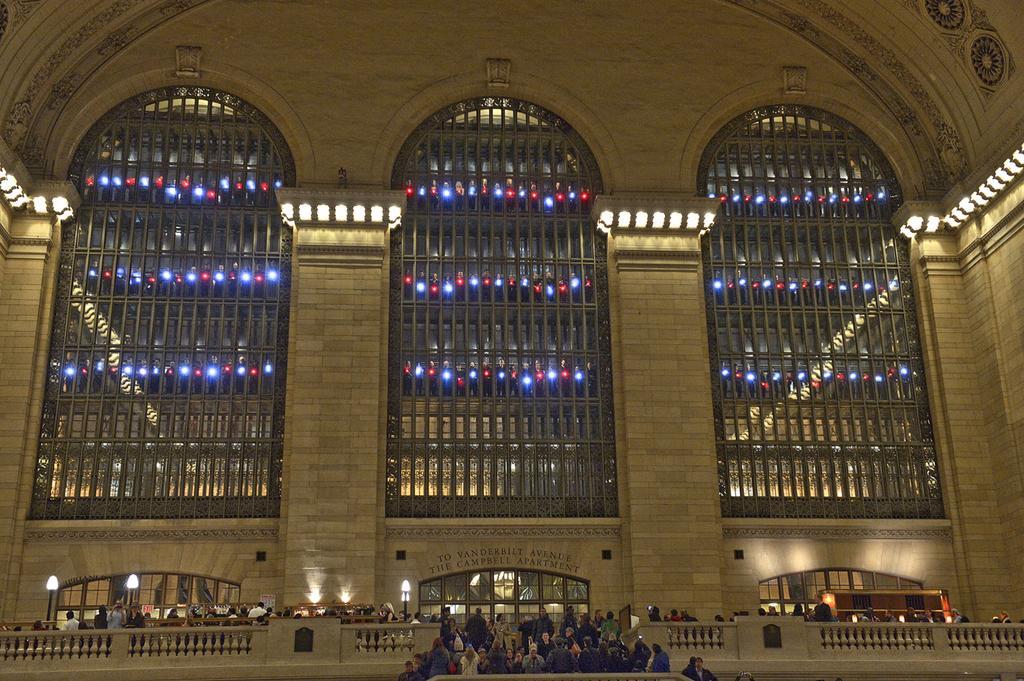How would you summarize this image in a sentence or two? In this image I can see the building , in front of the building there is a fence , beside the fence there are group of people visible , in front of the fence I can see the group of people and lights visible , there are few windows visible on the building. 